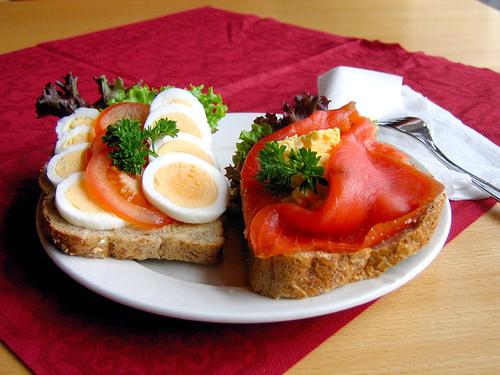Is this meal high in protein?
Keep it brief. Yes. What is on the sandwiches?
Short answer required. Egg. Is this a vegetarian meal?
Concise answer only. No. What is on the left side of the bread?
Quick response, please. Eggs and tomatoes. Are there vegetables?
Keep it brief. Yes. What is the green leaf called?
Short answer required. Parsley. What is the primary source of protein in this meal?
Write a very short answer. Eggs. 